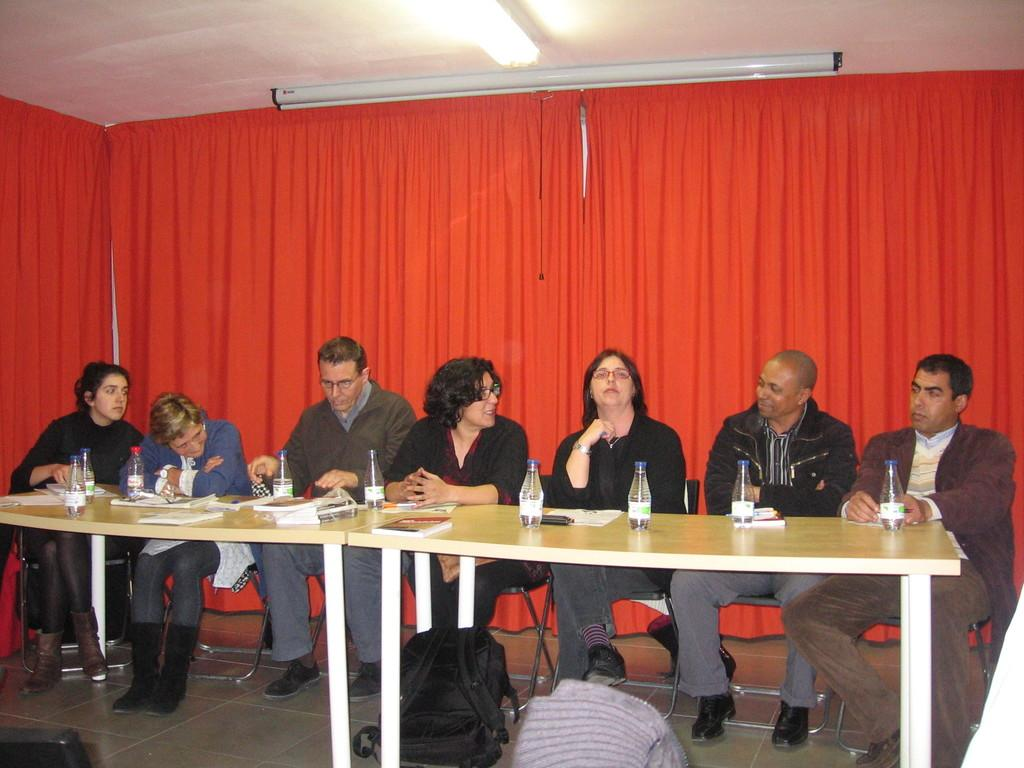How many people are in the image? There is a group of people in the image. What are the people doing in the image? The people are sitting on chairs. What is in front of the group of people? There is a table in front of the group of people. What is on the table in front of each person? Each person has a bottle in front of them. What can be seen behind the group of people? There is a red curtain present behind the group of people. Can you tell me how many goldfish are swimming in the bottle in front of the person on the left? There are no goldfish present in the image; each person has a bottle in front of them, but there is no indication of what is inside the bottles. 